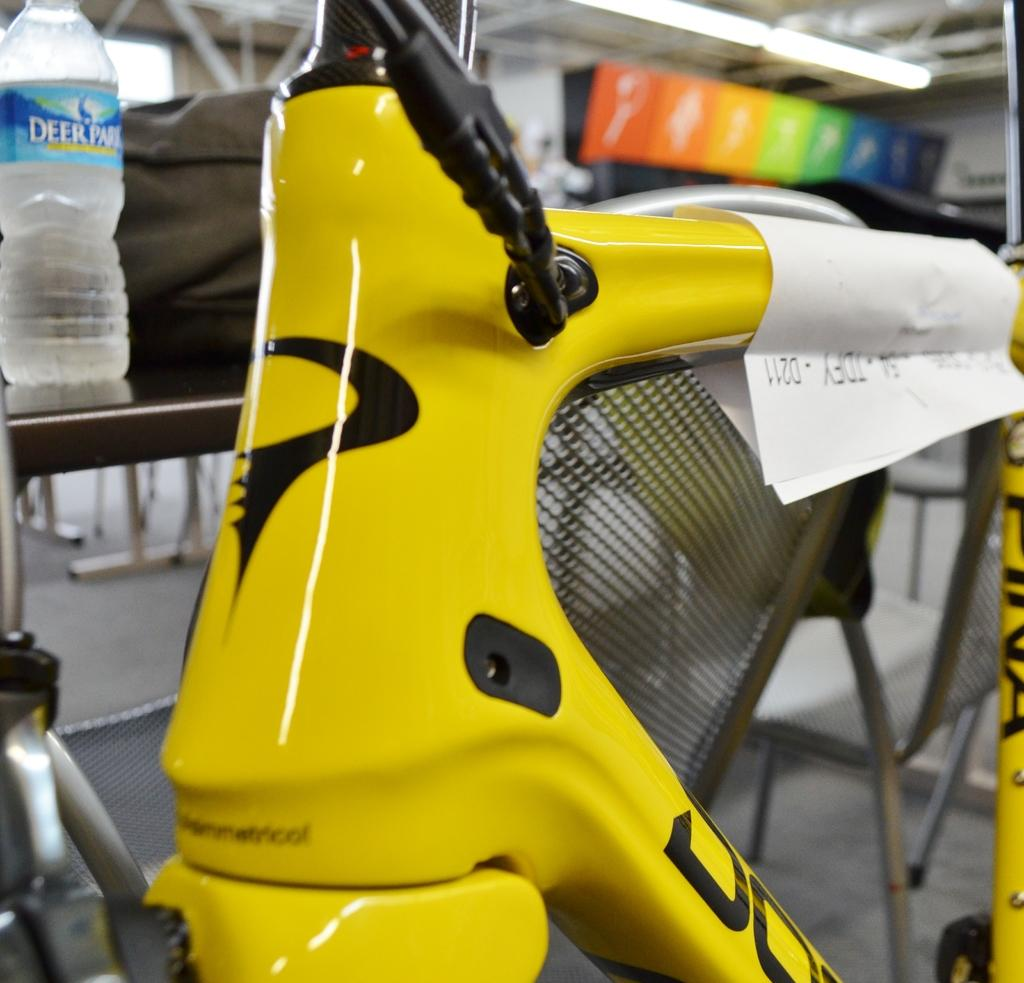What is the main object in the image? There is a bicycle in the image. What is located behind the bicycle? There is a water bottle behind the bicycle. What can be seen on a table in the image? There is a bag on a table in the image. What is visible in the background of the image? There is a hoarding and lights visible in the background of the image. What type of wine is being served at the baby's birthday party in the image? There is no baby, wine, or birthday party present in the image; it features a bicycle, water bottle, bag, hoarding, and lights. 